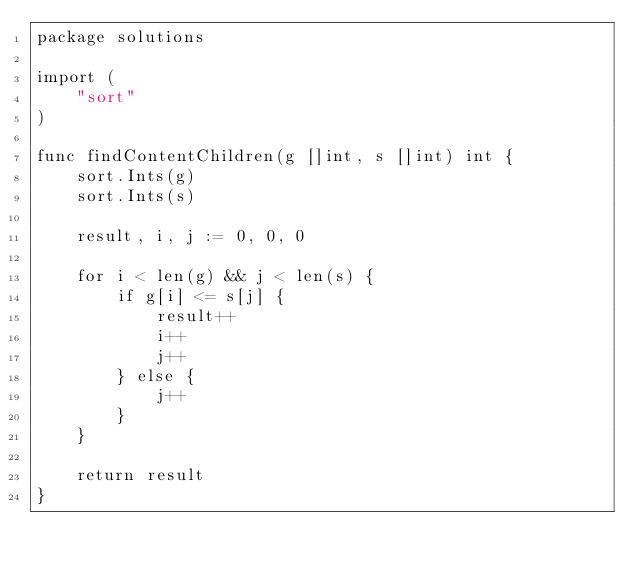<code> <loc_0><loc_0><loc_500><loc_500><_Go_>package solutions

import (
    "sort"
)

func findContentChildren(g []int, s []int) int {
    sort.Ints(g)
    sort.Ints(s)

    result, i, j := 0, 0, 0

    for i < len(g) && j < len(s) {
        if g[i] <= s[j] {
            result++
            i++
            j++
        } else {
            j++
        }
    }

    return result
}
</code> 